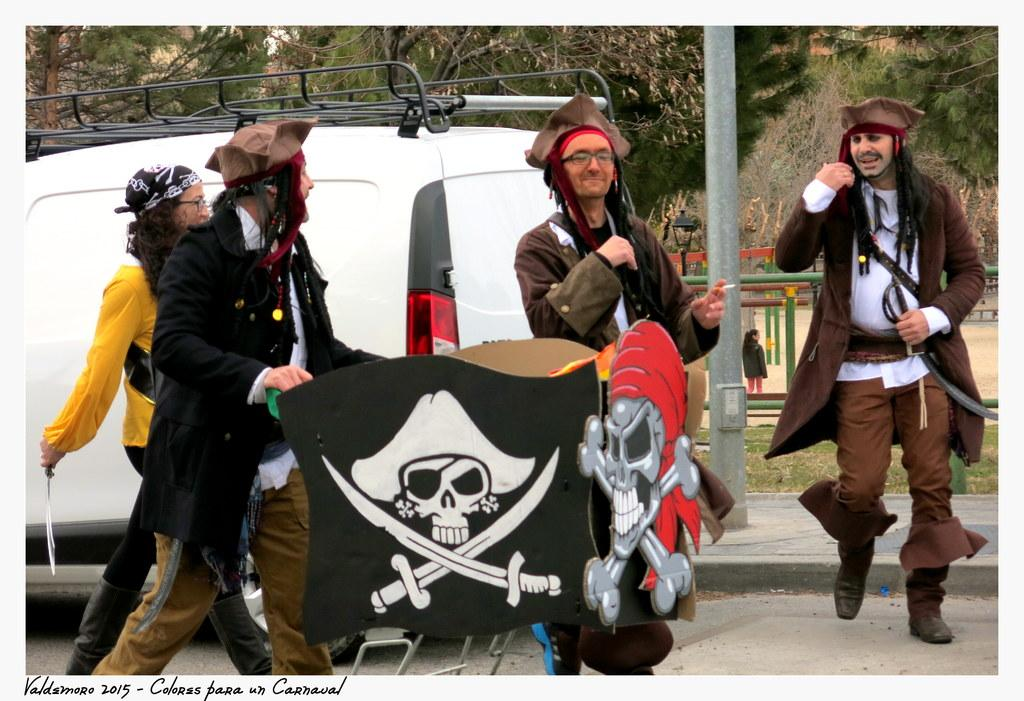What are the people in the image wearing? The people in the image are wearing different costumes. What is one person holding in the image? One person is holding a trolley in the image. What can be seen on a board in the image? There is a skull on a board in the image. What is visible in the background of the image? In the background, there is a vehicle, trees, a light-pole, and a pole. What type of office or company is depicted in the image? The image does not depict an office or company; it features people wearing costumes, a trolley, a skull on a board, and various background elements. How does the disgusting smell in the image affect the people? There is no mention of a disgusting smell in the image, so it cannot be determined how it would affect the people. 